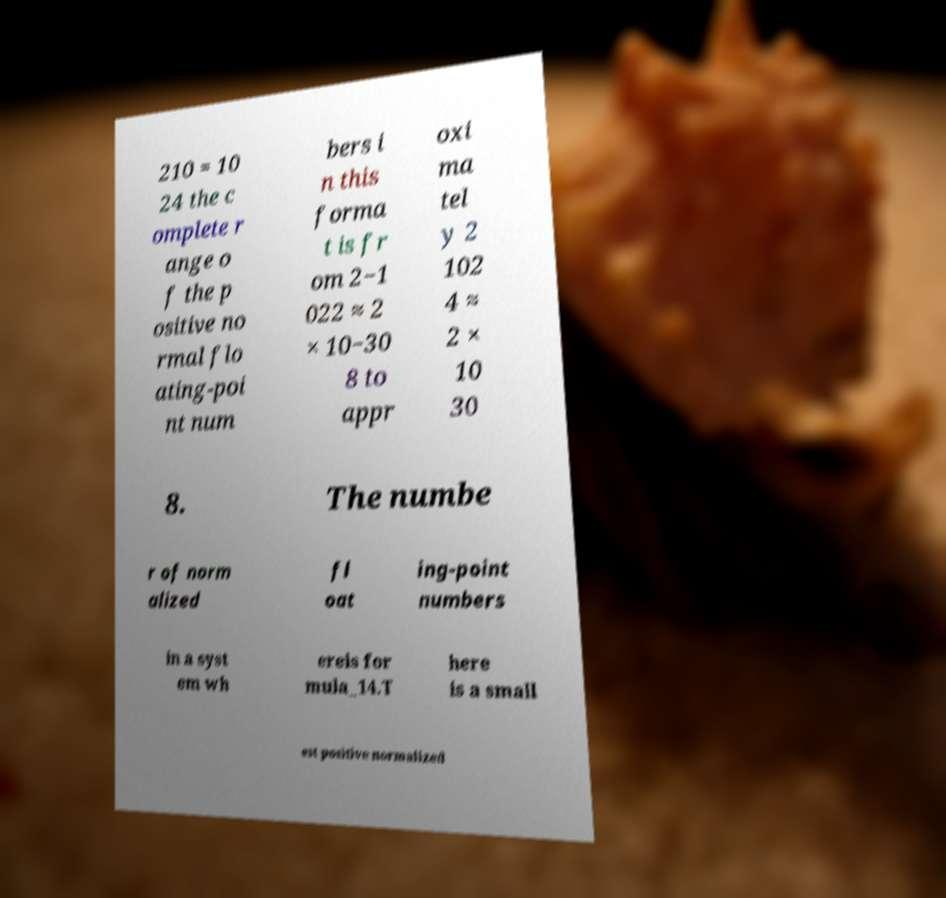There's text embedded in this image that I need extracted. Can you transcribe it verbatim? 210 = 10 24 the c omplete r ange o f the p ositive no rmal flo ating-poi nt num bers i n this forma t is fr om 2−1 022 ≈ 2 × 10−30 8 to appr oxi ma tel y 2 102 4 ≈ 2 × 10 30 8. The numbe r of norm alized fl oat ing-point numbers in a syst em wh ereis for mula_14.T here is a small est positive normalized 